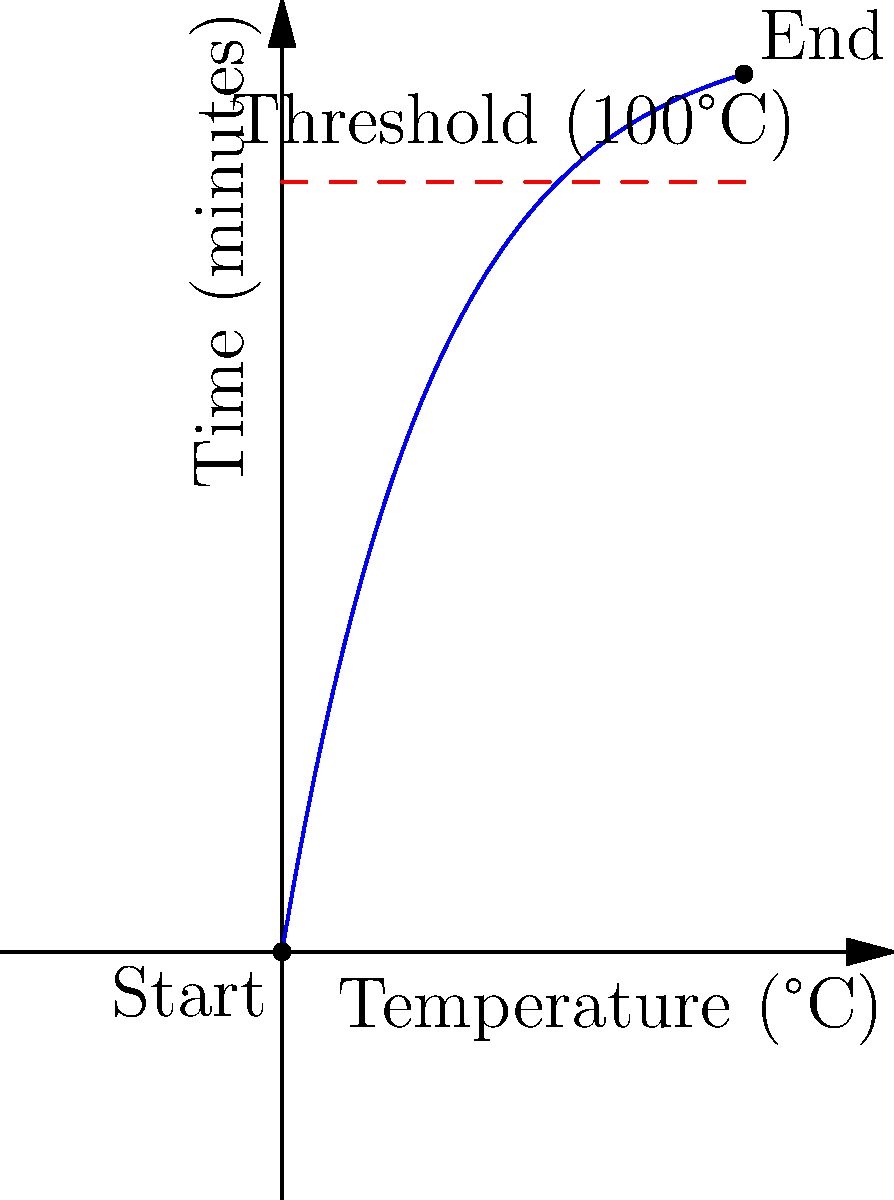In an autoclave used for sterilizing medical equipment, the temperature $T$ (in °C) follows the function $T(t) = 120 - 120e^{-0.05t}$, where $t$ is time in minutes. How long does it take for the equipment to reach a sterilization temperature of 100°C? To find the time when the temperature reaches 100°C, we need to solve the equation:

1) Set up the equation:
   $100 = 120 - 120e^{-0.05t}$

2) Rearrange to isolate the exponential term:
   $120e^{-0.05t} = 20$

3) Divide both sides by 120:
   $e^{-0.05t} = \frac{1}{6}$

4) Take the natural logarithm of both sides:
   $-0.05t = \ln(\frac{1}{6})$

5) Solve for $t$:
   $t = -\frac{\ln(\frac{1}{6})}{0.05}$

6) Calculate the result:
   $t \approx 36.89$ minutes

Therefore, it takes approximately 36.89 minutes for the equipment to reach a sterilization temperature of 100°C.
Answer: 36.89 minutes 